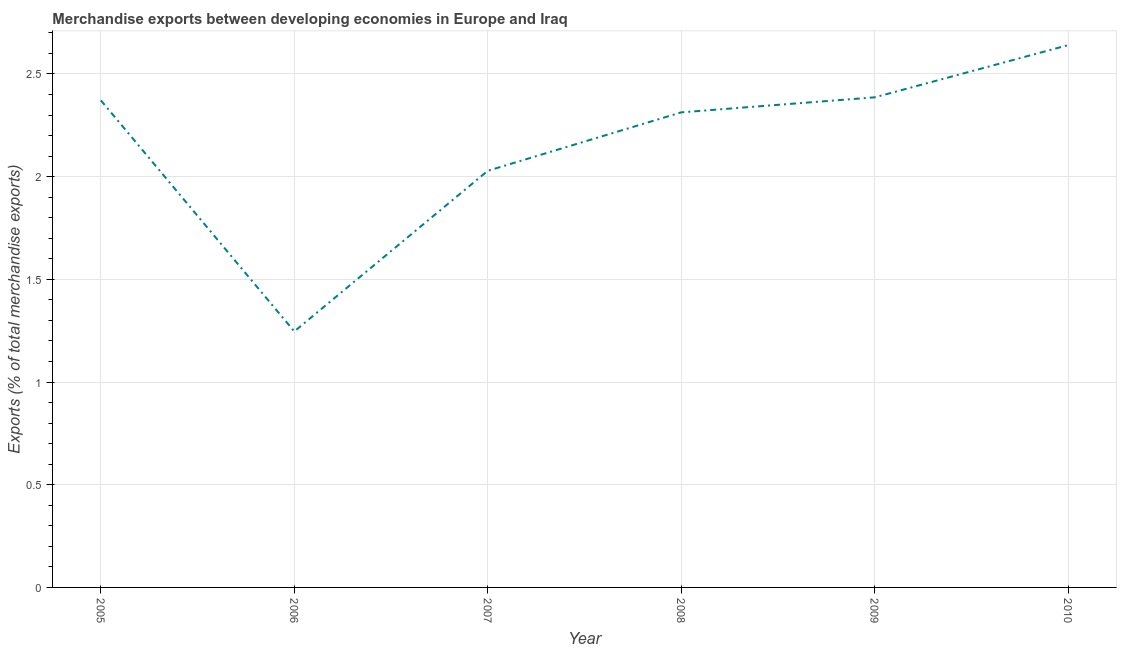What is the merchandise exports in 2005?
Make the answer very short. 2.37. Across all years, what is the maximum merchandise exports?
Your response must be concise. 2.64. Across all years, what is the minimum merchandise exports?
Your answer should be compact. 1.25. In which year was the merchandise exports maximum?
Offer a very short reply. 2010. In which year was the merchandise exports minimum?
Your answer should be very brief. 2006. What is the sum of the merchandise exports?
Keep it short and to the point. 12.99. What is the difference between the merchandise exports in 2008 and 2010?
Your response must be concise. -0.33. What is the average merchandise exports per year?
Offer a terse response. 2.16. What is the median merchandise exports?
Provide a short and direct response. 2.34. In how many years, is the merchandise exports greater than 1 %?
Make the answer very short. 6. What is the ratio of the merchandise exports in 2006 to that in 2008?
Give a very brief answer. 0.54. What is the difference between the highest and the second highest merchandise exports?
Ensure brevity in your answer.  0.25. What is the difference between the highest and the lowest merchandise exports?
Your answer should be very brief. 1.39. How many lines are there?
Your response must be concise. 1. How many years are there in the graph?
Provide a succinct answer. 6. Are the values on the major ticks of Y-axis written in scientific E-notation?
Provide a short and direct response. No. Does the graph contain any zero values?
Your response must be concise. No. What is the title of the graph?
Your answer should be compact. Merchandise exports between developing economies in Europe and Iraq. What is the label or title of the Y-axis?
Your answer should be very brief. Exports (% of total merchandise exports). What is the Exports (% of total merchandise exports) of 2005?
Your answer should be very brief. 2.37. What is the Exports (% of total merchandise exports) in 2006?
Ensure brevity in your answer.  1.25. What is the Exports (% of total merchandise exports) of 2007?
Your answer should be compact. 2.03. What is the Exports (% of total merchandise exports) of 2008?
Ensure brevity in your answer.  2.31. What is the Exports (% of total merchandise exports) of 2009?
Give a very brief answer. 2.39. What is the Exports (% of total merchandise exports) in 2010?
Your answer should be very brief. 2.64. What is the difference between the Exports (% of total merchandise exports) in 2005 and 2006?
Ensure brevity in your answer.  1.13. What is the difference between the Exports (% of total merchandise exports) in 2005 and 2007?
Keep it short and to the point. 0.34. What is the difference between the Exports (% of total merchandise exports) in 2005 and 2008?
Your answer should be compact. 0.06. What is the difference between the Exports (% of total merchandise exports) in 2005 and 2009?
Keep it short and to the point. -0.01. What is the difference between the Exports (% of total merchandise exports) in 2005 and 2010?
Make the answer very short. -0.27. What is the difference between the Exports (% of total merchandise exports) in 2006 and 2007?
Make the answer very short. -0.78. What is the difference between the Exports (% of total merchandise exports) in 2006 and 2008?
Offer a very short reply. -1.07. What is the difference between the Exports (% of total merchandise exports) in 2006 and 2009?
Provide a succinct answer. -1.14. What is the difference between the Exports (% of total merchandise exports) in 2006 and 2010?
Make the answer very short. -1.39. What is the difference between the Exports (% of total merchandise exports) in 2007 and 2008?
Your answer should be compact. -0.28. What is the difference between the Exports (% of total merchandise exports) in 2007 and 2009?
Ensure brevity in your answer.  -0.36. What is the difference between the Exports (% of total merchandise exports) in 2007 and 2010?
Your answer should be compact. -0.61. What is the difference between the Exports (% of total merchandise exports) in 2008 and 2009?
Your answer should be compact. -0.07. What is the difference between the Exports (% of total merchandise exports) in 2008 and 2010?
Ensure brevity in your answer.  -0.33. What is the difference between the Exports (% of total merchandise exports) in 2009 and 2010?
Provide a short and direct response. -0.25. What is the ratio of the Exports (% of total merchandise exports) in 2005 to that in 2006?
Ensure brevity in your answer.  1.9. What is the ratio of the Exports (% of total merchandise exports) in 2005 to that in 2007?
Offer a terse response. 1.17. What is the ratio of the Exports (% of total merchandise exports) in 2005 to that in 2008?
Provide a short and direct response. 1.02. What is the ratio of the Exports (% of total merchandise exports) in 2005 to that in 2009?
Your answer should be compact. 0.99. What is the ratio of the Exports (% of total merchandise exports) in 2005 to that in 2010?
Keep it short and to the point. 0.9. What is the ratio of the Exports (% of total merchandise exports) in 2006 to that in 2007?
Provide a short and direct response. 0.61. What is the ratio of the Exports (% of total merchandise exports) in 2006 to that in 2008?
Offer a very short reply. 0.54. What is the ratio of the Exports (% of total merchandise exports) in 2006 to that in 2009?
Your response must be concise. 0.52. What is the ratio of the Exports (% of total merchandise exports) in 2006 to that in 2010?
Your answer should be compact. 0.47. What is the ratio of the Exports (% of total merchandise exports) in 2007 to that in 2008?
Give a very brief answer. 0.88. What is the ratio of the Exports (% of total merchandise exports) in 2007 to that in 2010?
Ensure brevity in your answer.  0.77. What is the ratio of the Exports (% of total merchandise exports) in 2008 to that in 2009?
Keep it short and to the point. 0.97. What is the ratio of the Exports (% of total merchandise exports) in 2008 to that in 2010?
Offer a very short reply. 0.88. What is the ratio of the Exports (% of total merchandise exports) in 2009 to that in 2010?
Your answer should be compact. 0.9. 